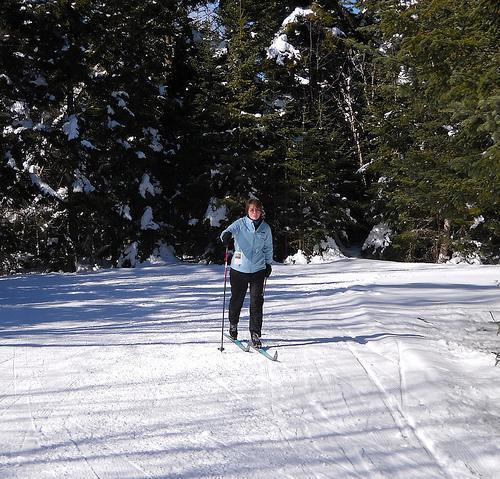How many people are pictured?
Give a very brief answer. 1. 